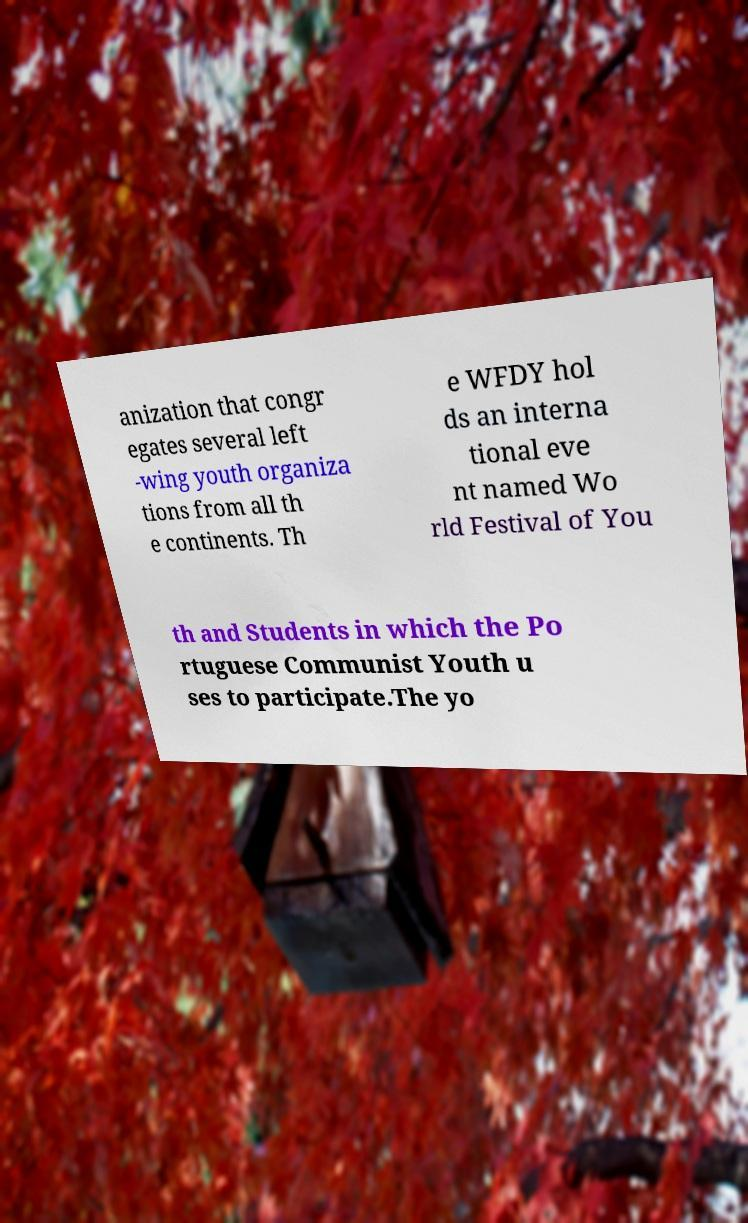Could you extract and type out the text from this image? anization that congr egates several left -wing youth organiza tions from all th e continents. Th e WFDY hol ds an interna tional eve nt named Wo rld Festival of You th and Students in which the Po rtuguese Communist Youth u ses to participate.The yo 